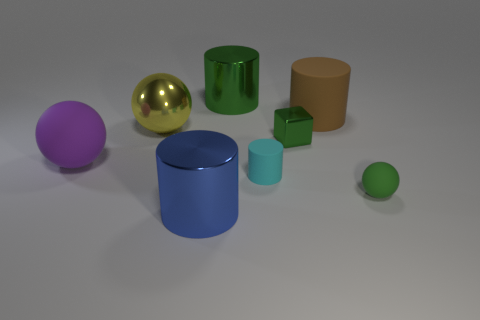Subtract all small matte spheres. How many spheres are left? 2 Add 1 tiny purple blocks. How many objects exist? 9 Subtract all green balls. How many balls are left? 2 Subtract all spheres. How many objects are left? 5 Subtract 1 blue cylinders. How many objects are left? 7 Subtract 1 cubes. How many cubes are left? 0 Subtract all red balls. Subtract all brown cylinders. How many balls are left? 3 Subtract all big cyan cylinders. Subtract all large cylinders. How many objects are left? 5 Add 5 green rubber spheres. How many green rubber spheres are left? 6 Add 7 small cyan metallic objects. How many small cyan metallic objects exist? 7 